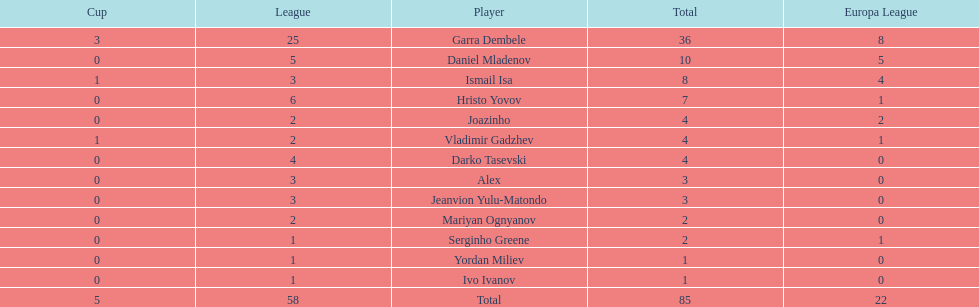Which players have at least 4 in the europa league? Garra Dembele, Daniel Mladenov, Ismail Isa. 